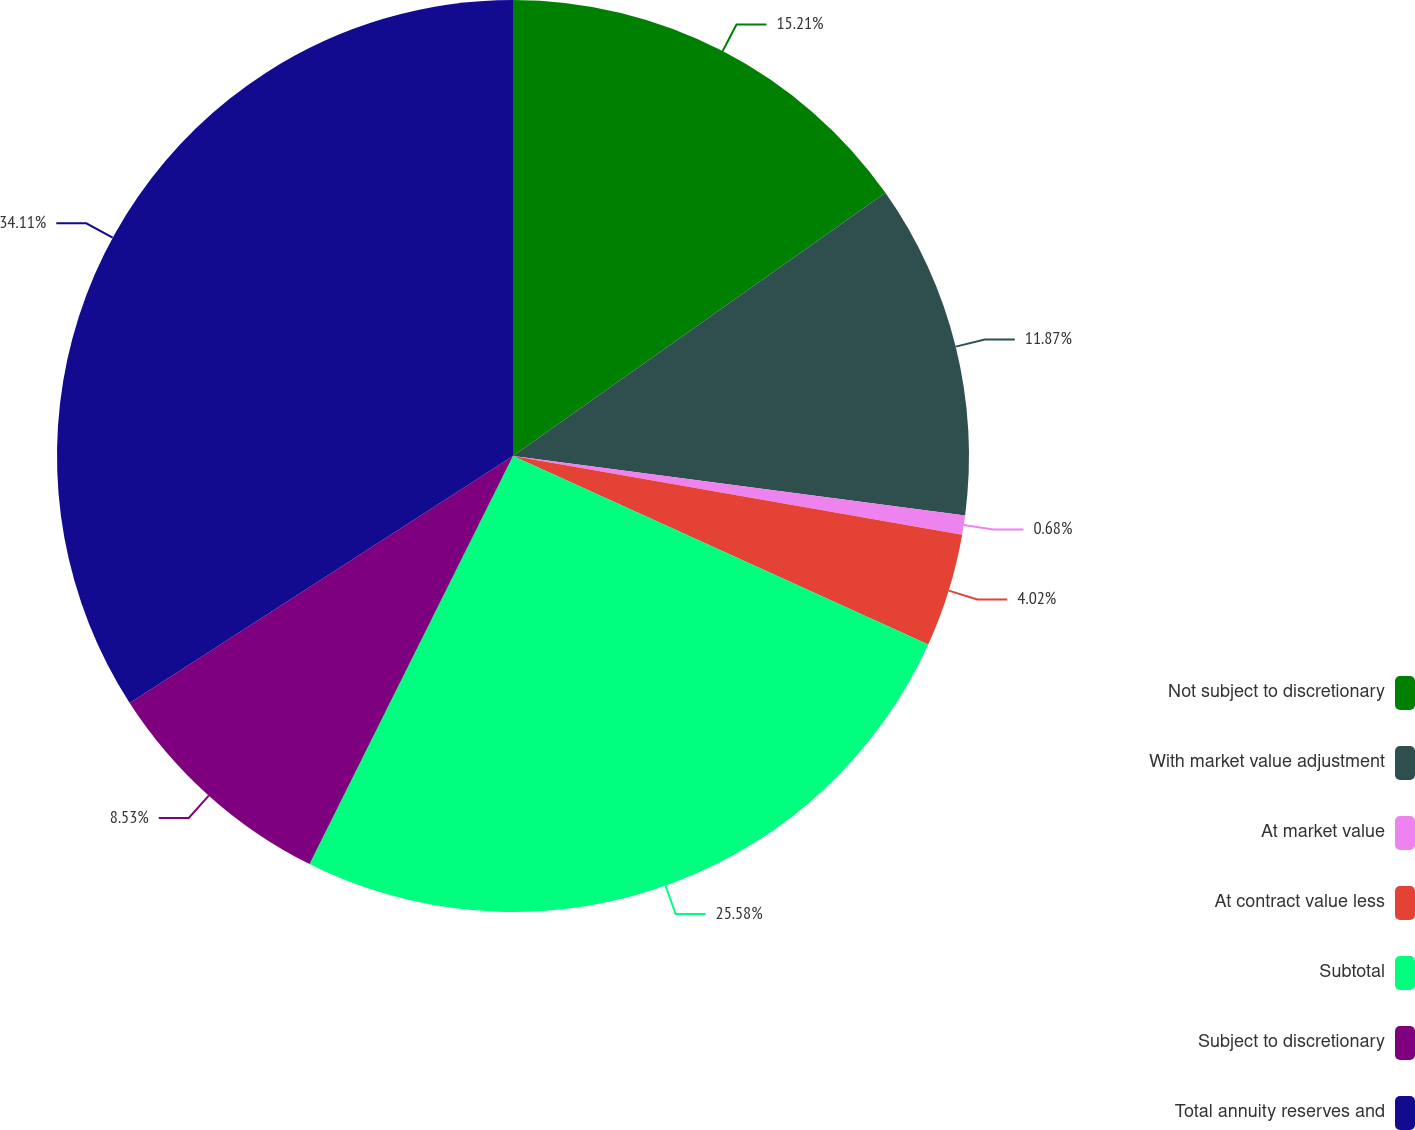<chart> <loc_0><loc_0><loc_500><loc_500><pie_chart><fcel>Not subject to discretionary<fcel>With market value adjustment<fcel>At market value<fcel>At contract value less<fcel>Subtotal<fcel>Subject to discretionary<fcel>Total annuity reserves and<nl><fcel>15.21%<fcel>11.87%<fcel>0.68%<fcel>4.02%<fcel>25.58%<fcel>8.53%<fcel>34.11%<nl></chart> 